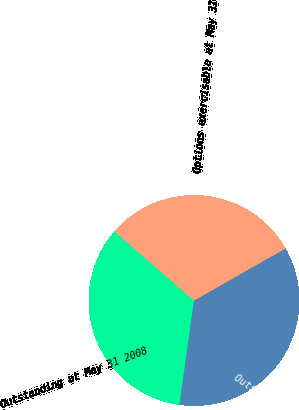<chart> <loc_0><loc_0><loc_500><loc_500><pie_chart><fcel>Outstanding at May 31 2008<fcel>Outstanding at May 31 2009<fcel>Options exercisable at May 31<nl><fcel>34.18%<fcel>35.44%<fcel>30.38%<nl></chart> 